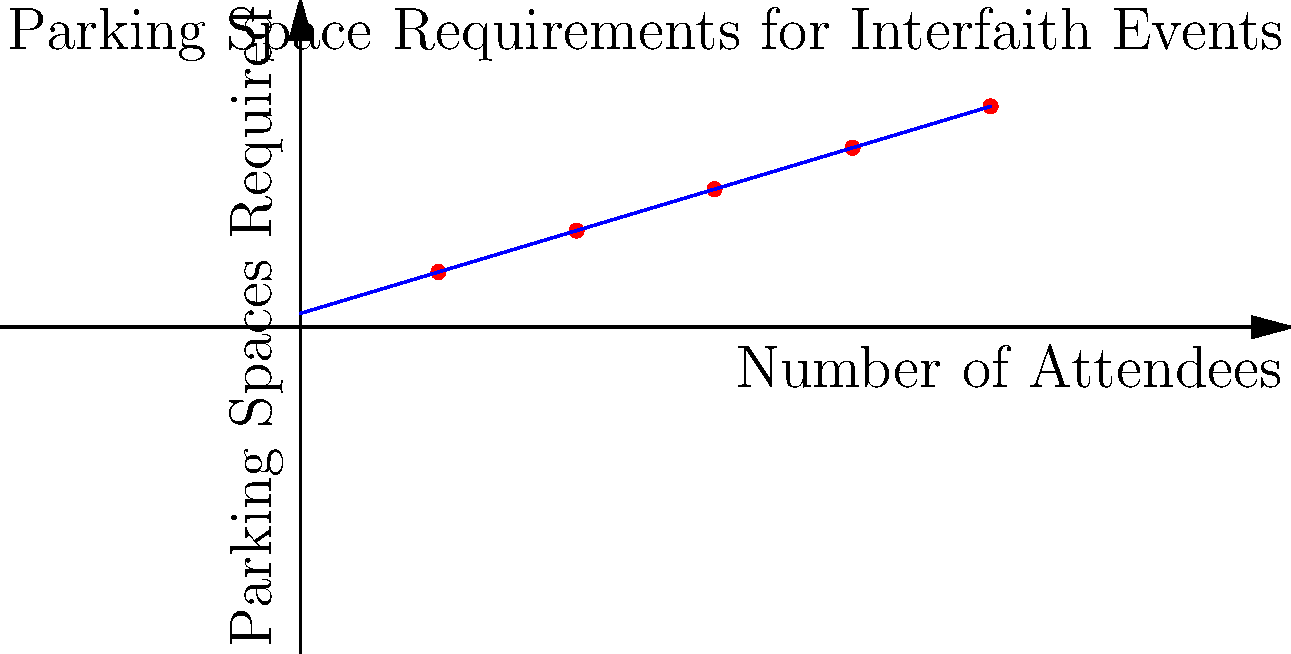Based on the graph showing the relationship between the number of attendees and parking spaces required for interfaith events, estimate the number of parking spaces needed for an event with 350 attendees. How might this information help in planning a parking lot layout for varying attendance? To answer this question, we'll follow these steps:

1. Understand the graph:
   - The x-axis represents the number of attendees
   - The y-axis represents the parking spaces required
   - The blue line represents the best-fit line for the data points

2. Identify the equation of the best-fit line:
   The line appears to follow the equation $y = 0.3x + 10$, where:
   - $y$ is the number of parking spaces required
   - $x$ is the number of attendees

3. Calculate the parking spaces for 350 attendees:
   $y = 0.3 * 350 + 10 = 105 + 10 = 115$ parking spaces

4. Consider the implications for planning:
   - This linear relationship allows for easy estimation of parking needs for various attendance levels
   - It helps in designing flexible parking layouts that can accommodate different event sizes
   - Planners can use this information to:
     a) Determine the maximum event size based on available parking
     b) Plan for overflow parking for larger events
     c) Consider shared parking arrangements with nearby facilities for peak attendance

5. Think about the ecumenical aspect:
   - Different faiths may have varying transportation needs (e.g., more carpooling, public transit use)
   - Consider accessibility requirements for diverse attendees
   - Plan for potential shuttle services from remote parking areas for larger interfaith gatherings

By using this data-driven approach, event planners can create more efficient and accommodating parking layouts for interfaith events of various sizes, promoting inclusivity and accessibility in the community.
Answer: 115 parking spaces; enables flexible, data-driven parking planning for various event sizes 